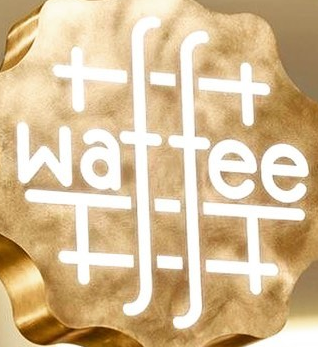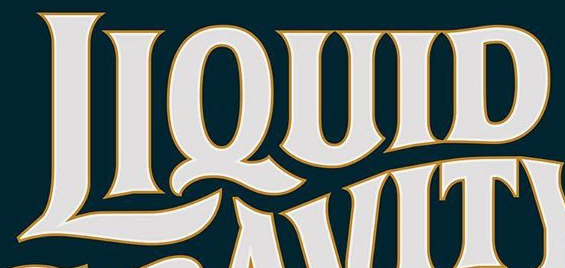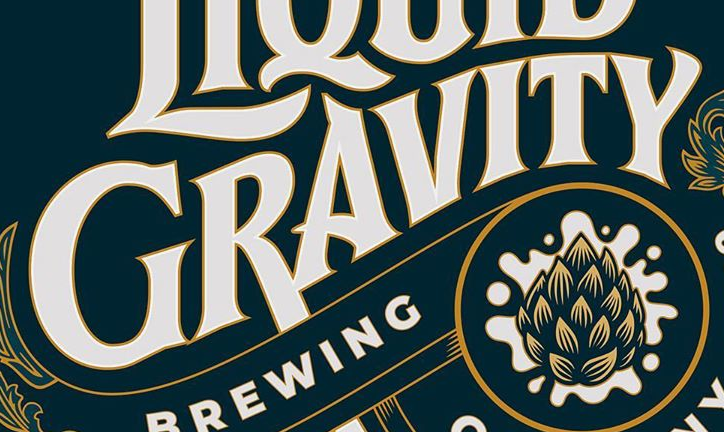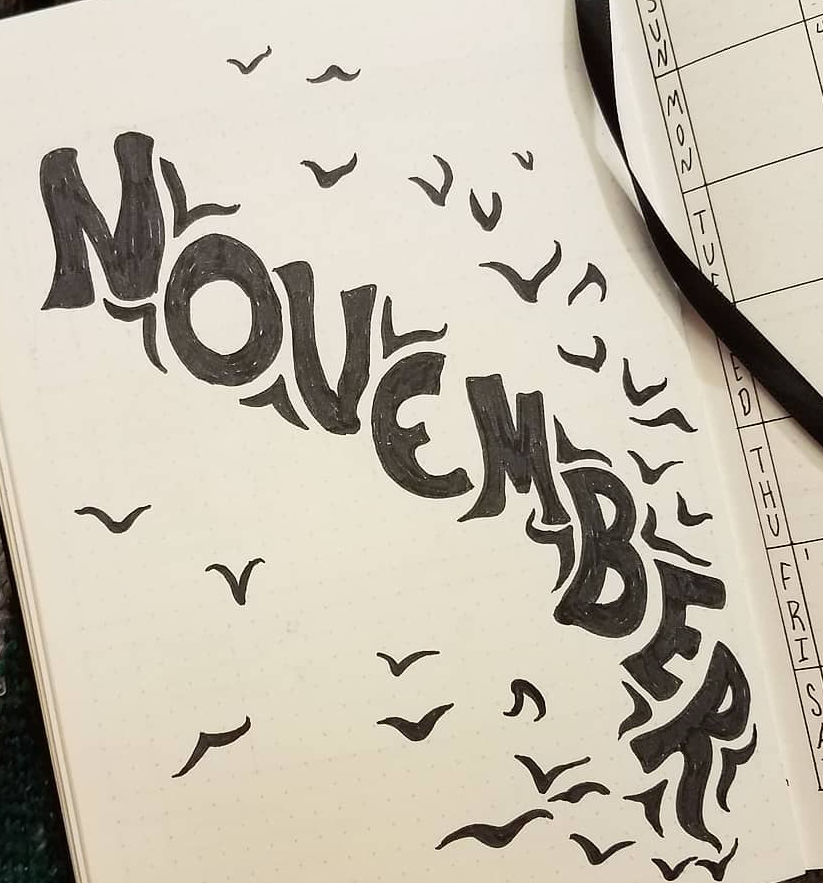What text is displayed in these images sequentially, separated by a semicolon? waffee; LIQUID; GRAVITY; NOVEMBER 